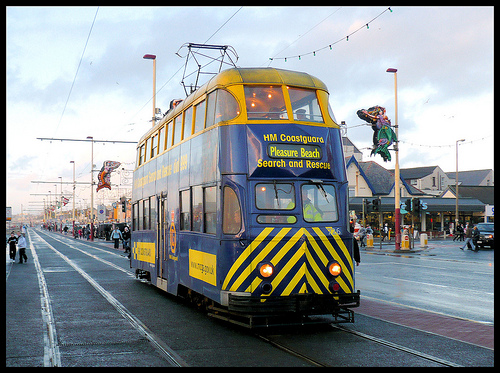<image>
Is there a bus on the track? Yes. Looking at the image, I can see the bus is positioned on top of the track, with the track providing support. 